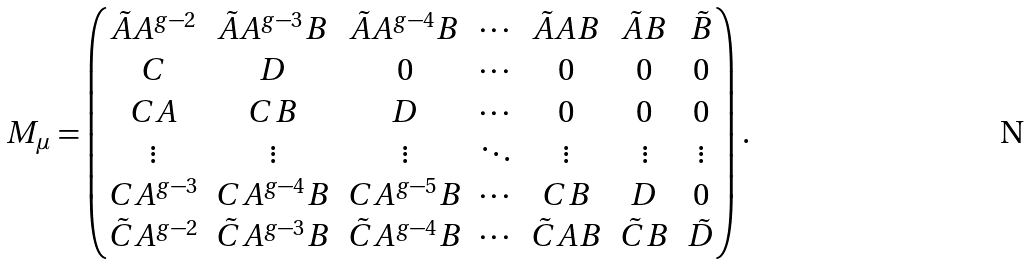Convert formula to latex. <formula><loc_0><loc_0><loc_500><loc_500>M _ { \mu } = \begin{pmatrix} \tilde { A } A ^ { g - 2 } & \tilde { A } A ^ { g - 3 } B & \tilde { A } A ^ { g - 4 } B & \cdots & \tilde { A } A B & \tilde { A } B & \tilde { B } \\ C & D & 0 & \cdots & 0 & 0 & 0 \\ C A & C B & D & \cdots & 0 & 0 & 0 \\ \vdots & \vdots & \vdots & \ddots & \vdots & \vdots & \vdots \\ C A ^ { g - 3 } & C A ^ { g - 4 } B & C A ^ { g - 5 } B & \cdots & C B & D & 0 \\ \tilde { C } A ^ { g - 2 } & \tilde { C } A ^ { g - 3 } B & \tilde { C } A ^ { g - 4 } B & \cdots & \tilde { C } A B & \tilde { C } B & \tilde { D } \\ \end{pmatrix} .</formula> 